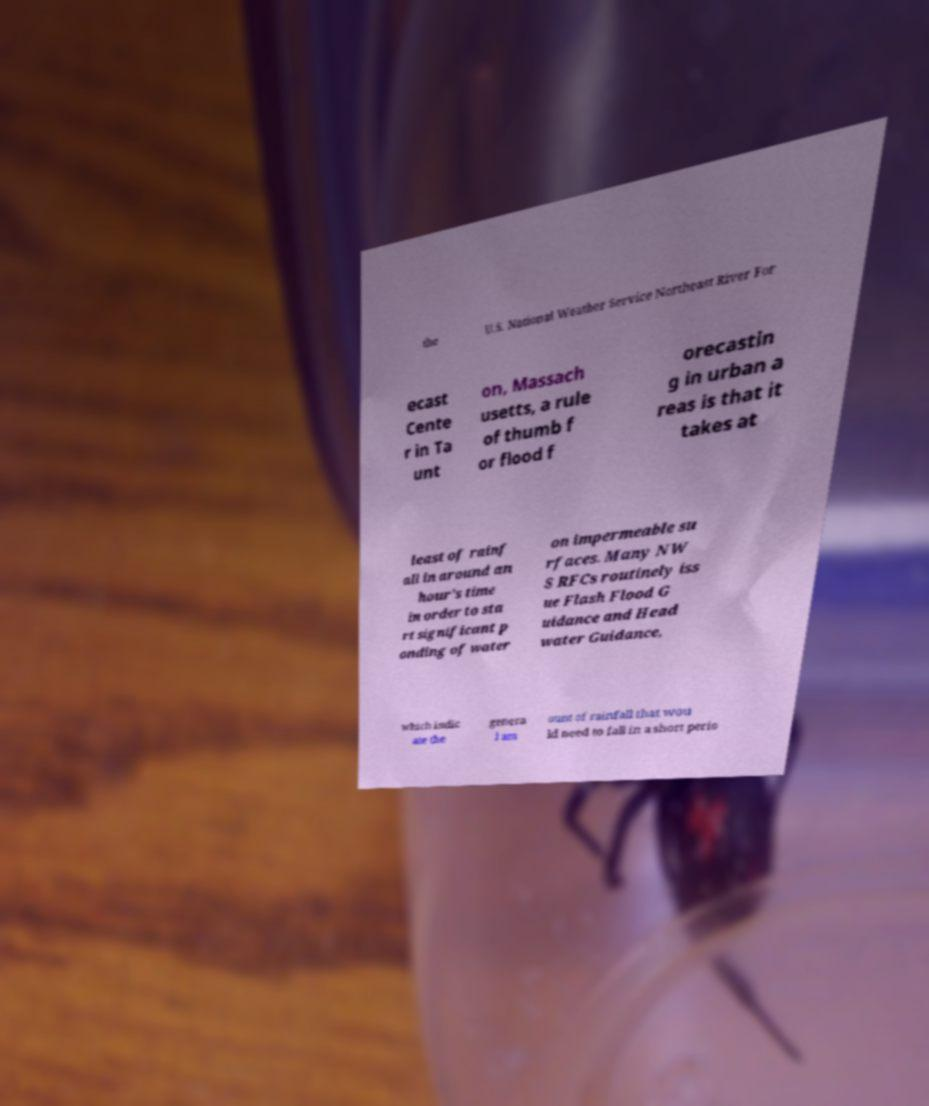Could you extract and type out the text from this image? the U.S. National Weather Service Northeast River For ecast Cente r in Ta unt on, Massach usetts, a rule of thumb f or flood f orecastin g in urban a reas is that it takes at least of rainf all in around an hour's time in order to sta rt significant p onding of water on impermeable su rfaces. Many NW S RFCs routinely iss ue Flash Flood G uidance and Head water Guidance, which indic ate the genera l am ount of rainfall that wou ld need to fall in a short perio 